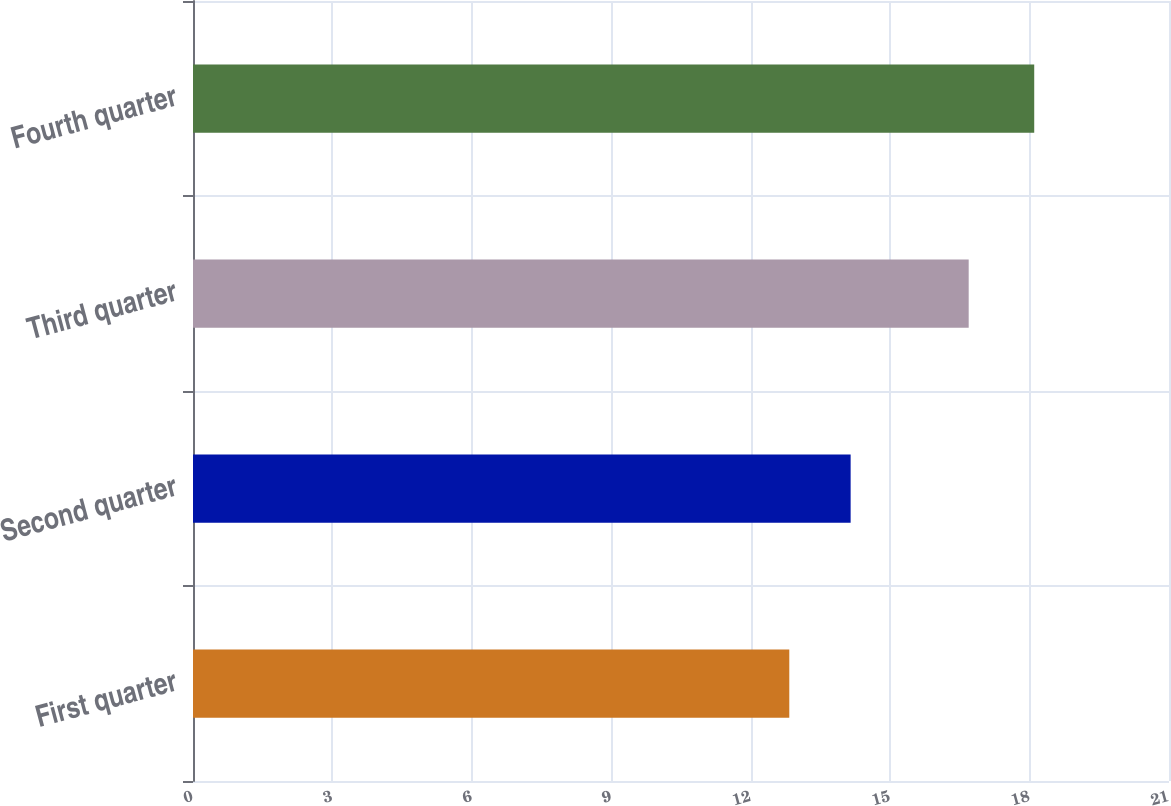<chart> <loc_0><loc_0><loc_500><loc_500><bar_chart><fcel>First quarter<fcel>Second quarter<fcel>Third quarter<fcel>Fourth quarter<nl><fcel>12.83<fcel>14.15<fcel>16.69<fcel>18.1<nl></chart> 